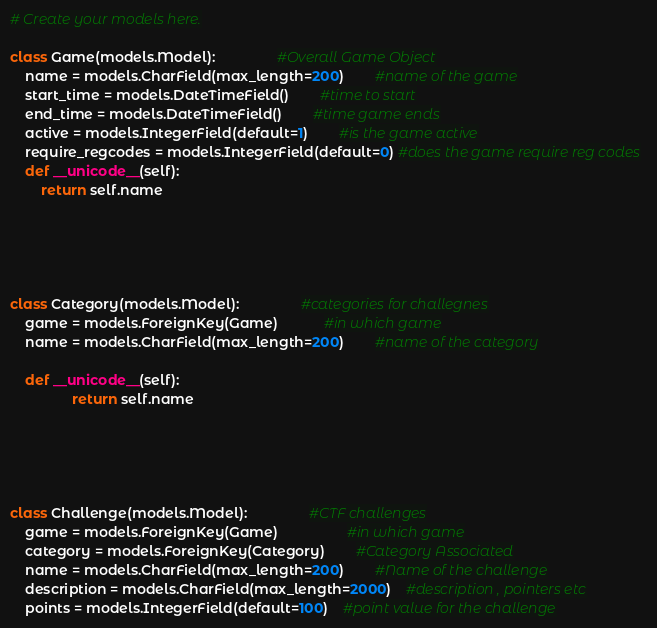<code> <loc_0><loc_0><loc_500><loc_500><_Python_>


# Create your models here.

class Game(models.Model):				#Overall Game Object
	name = models.CharField(max_length=200)		#name of the game
	start_time = models.DateTimeField()		#time to start
	end_time = models.DateTimeField()		#time game ends
	active = models.IntegerField(default=1)		#is the game active
	require_regcodes = models.IntegerField(default=0) #does the game require reg codes
	def __unicode__(self):
		return self.name





class Category(models.Model):				#categories for challegnes
	game = models.ForeignKey(Game)			#in which game
	name = models.CharField(max_length=200)		#name of the category
	
	def __unicode__(self):
                return self.name





class Challenge(models.Model):				#CTF challenges
	game = models.ForeignKey(Game)                  #in which game
	category = models.ForeignKey(Category)		#Category Associated
	name = models.CharField(max_length=200)		#Name of the challenge
	description = models.CharField(max_length=2000)	#description , pointers etc
	points = models.IntegerField(default=100)	#point value for the challenge</code> 